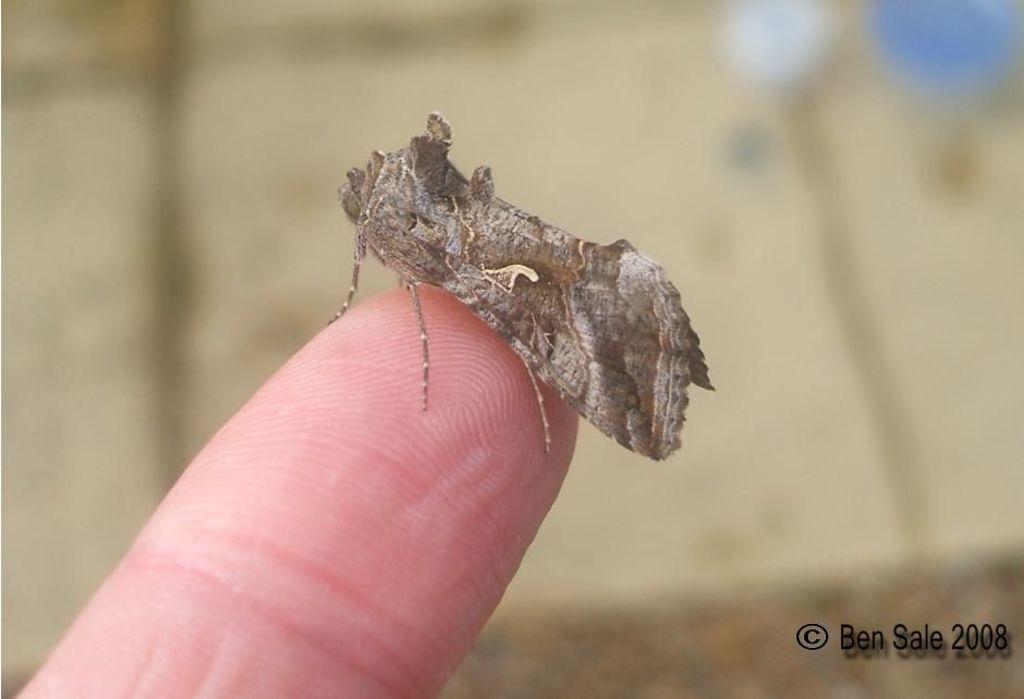Describe this image in one or two sentences. In this image we can see an insect on the person's finger. 